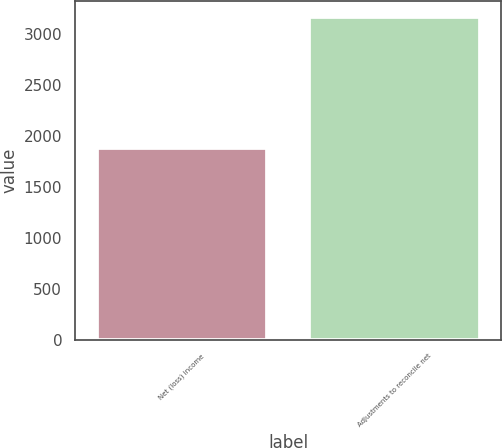Convert chart. <chart><loc_0><loc_0><loc_500><loc_500><bar_chart><fcel>Net (loss) income<fcel>Adjustments to reconcile net<nl><fcel>1886<fcel>3166<nl></chart> 